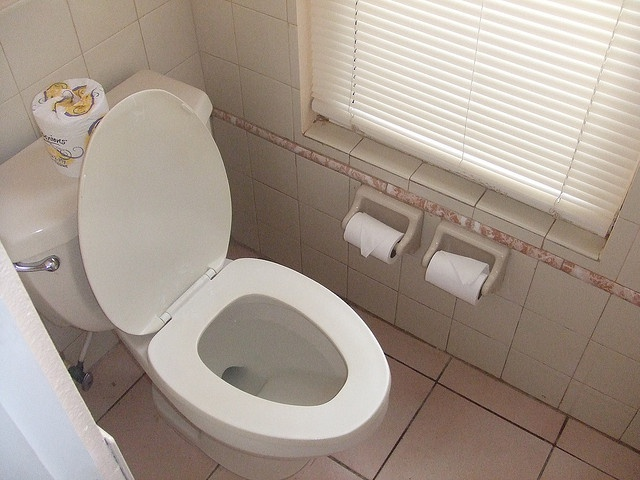Describe the objects in this image and their specific colors. I can see a toilet in darkgray, lightgray, and gray tones in this image. 